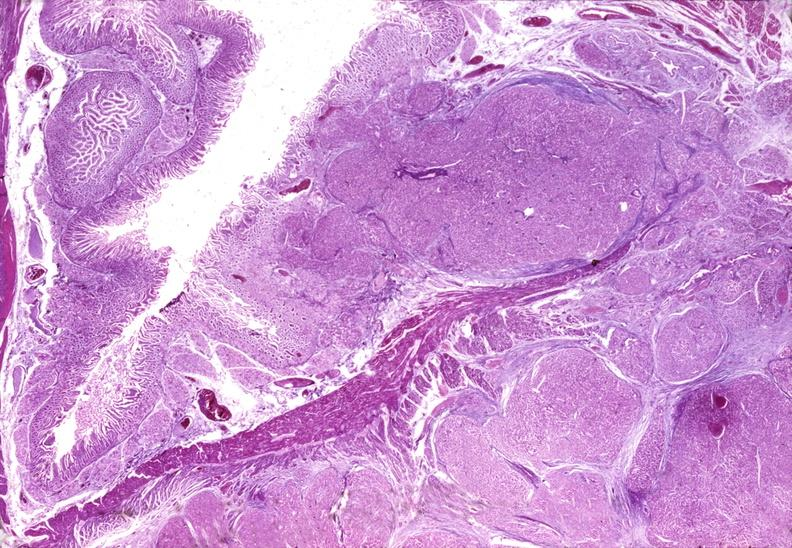does this image show islet cell carcinoma?
Answer the question using a single word or phrase. Yes 